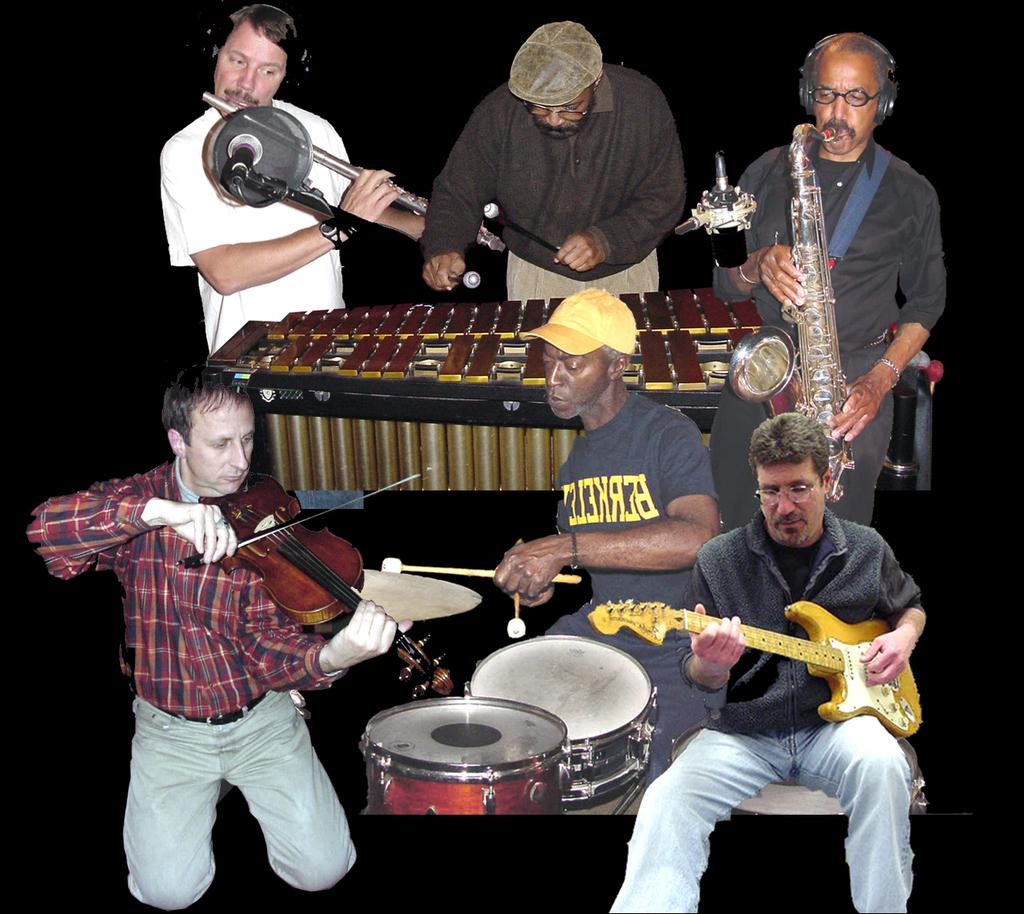What is the color of the background in the image? The background of the image is dark. What are the people in the image doing? There are people standing and playing musical instruments, as well as three men sitting and playing musical instruments. How many cherries can be seen on the doll in the image? There is no doll or cherries present in the image. What type of soap is being used by the people playing musical instruments? There is no soap present in the image; the people are playing musical instruments. 